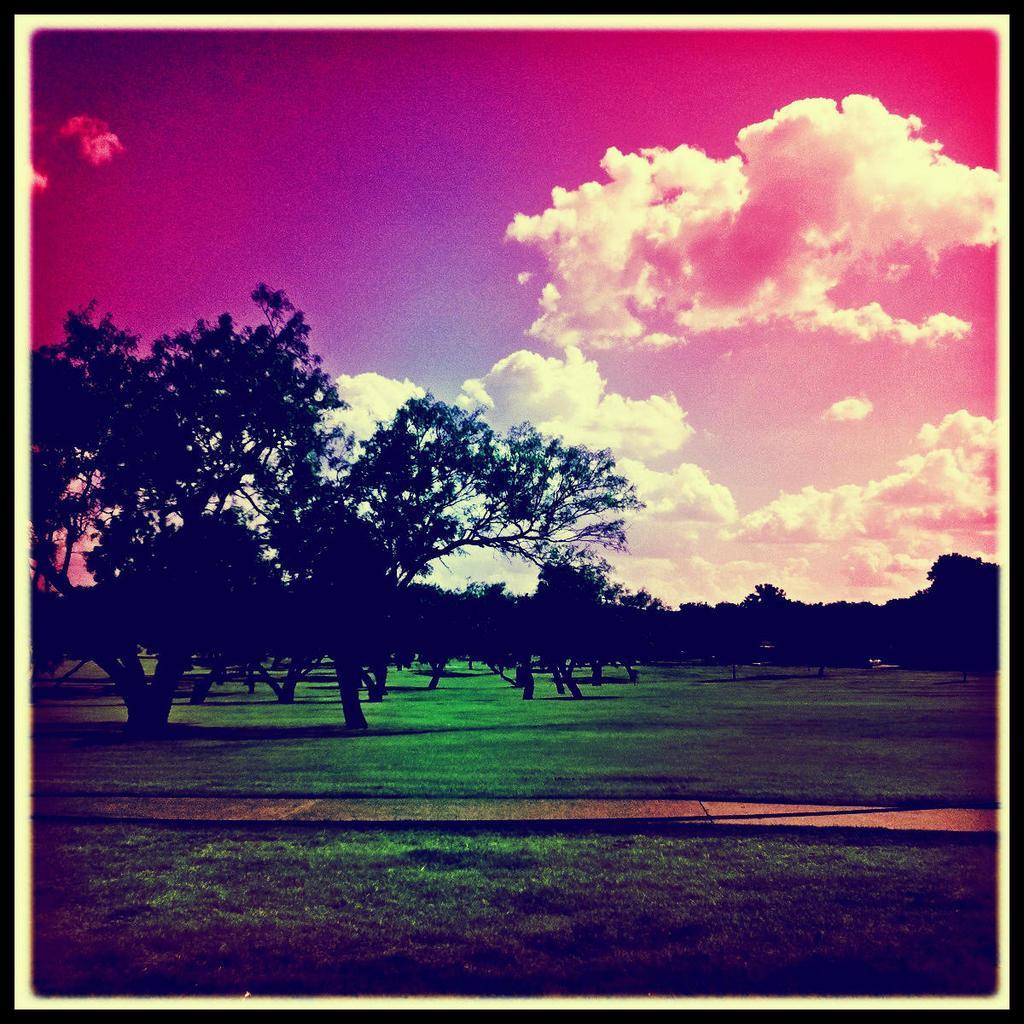In one or two sentences, can you explain what this image depicts? In this picture we can observe some trees and grass on the ground. In the background we can observe a sky with some clouds. We can observe a pink color in the sky. 